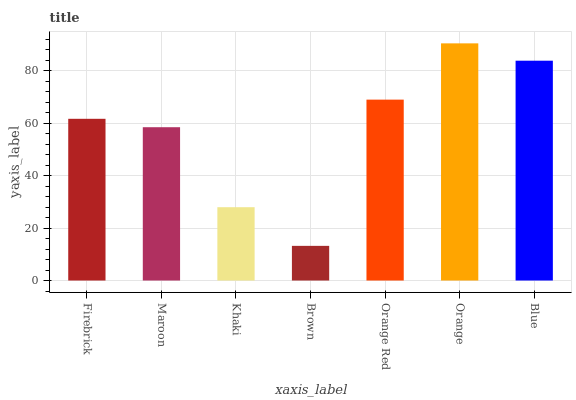Is Brown the minimum?
Answer yes or no. Yes. Is Orange the maximum?
Answer yes or no. Yes. Is Maroon the minimum?
Answer yes or no. No. Is Maroon the maximum?
Answer yes or no. No. Is Firebrick greater than Maroon?
Answer yes or no. Yes. Is Maroon less than Firebrick?
Answer yes or no. Yes. Is Maroon greater than Firebrick?
Answer yes or no. No. Is Firebrick less than Maroon?
Answer yes or no. No. Is Firebrick the high median?
Answer yes or no. Yes. Is Firebrick the low median?
Answer yes or no. Yes. Is Brown the high median?
Answer yes or no. No. Is Orange the low median?
Answer yes or no. No. 